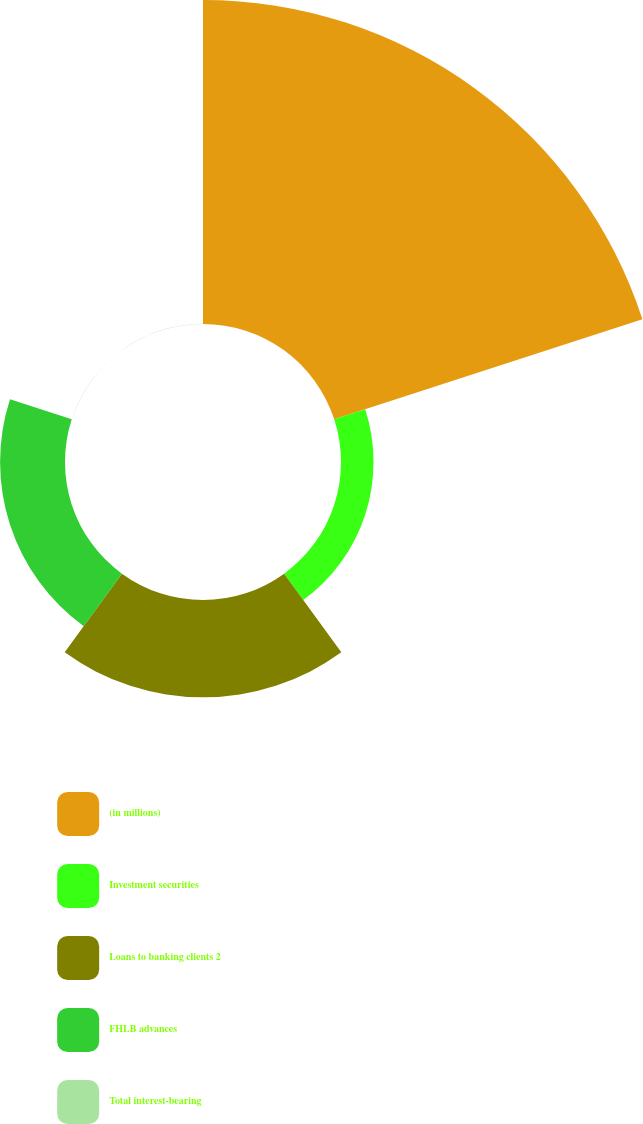<chart> <loc_0><loc_0><loc_500><loc_500><pie_chart><fcel>(in millions)<fcel>Investment securities<fcel>Loans to banking clients 2<fcel>FHLB advances<fcel>Total interest-bearing<nl><fcel>62.43%<fcel>6.27%<fcel>18.75%<fcel>12.51%<fcel>0.03%<nl></chart> 